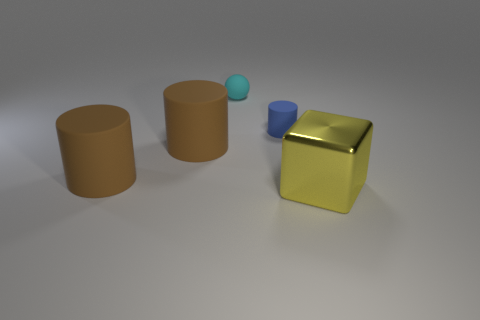Add 3 small cylinders. How many objects exist? 8 Subtract all large brown matte cylinders. How many cylinders are left? 1 Subtract all cylinders. How many objects are left? 2 Subtract 1 balls. How many balls are left? 0 Subtract all brown cylinders. How many cylinders are left? 1 Subtract 0 green cylinders. How many objects are left? 5 Subtract all blue cylinders. Subtract all yellow blocks. How many cylinders are left? 2 Subtract all gray cylinders. How many green blocks are left? 0 Subtract all yellow things. Subtract all cylinders. How many objects are left? 1 Add 4 yellow metallic blocks. How many yellow metallic blocks are left? 5 